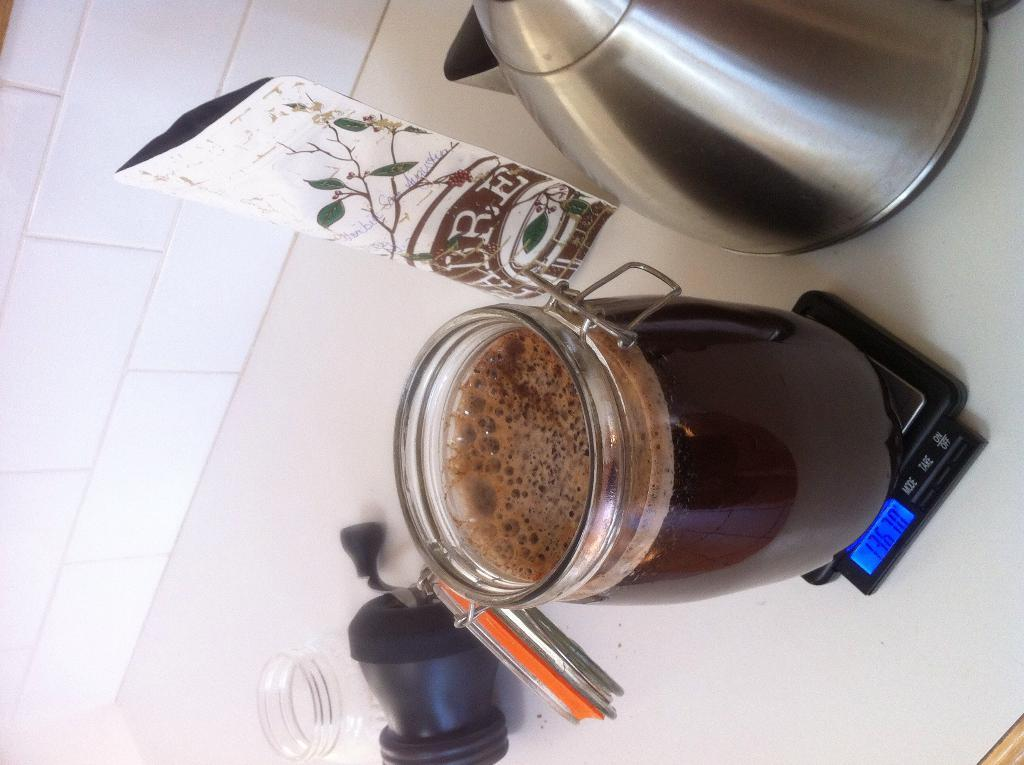What can be seen on the gadget in the image? There is a glass jar on the gadget in the image. What is inside the glass jar? The glass jar contains liquid. What is located on the table in the image? There is a vessel on a table in the image. What else can be found on the table? There are objects on the table. What is visible in the background of the image? There is a wall in the image. What statement does the liquid make in the image? The liquid does not make a statement in the image; it is simply contained within the glass jar. 